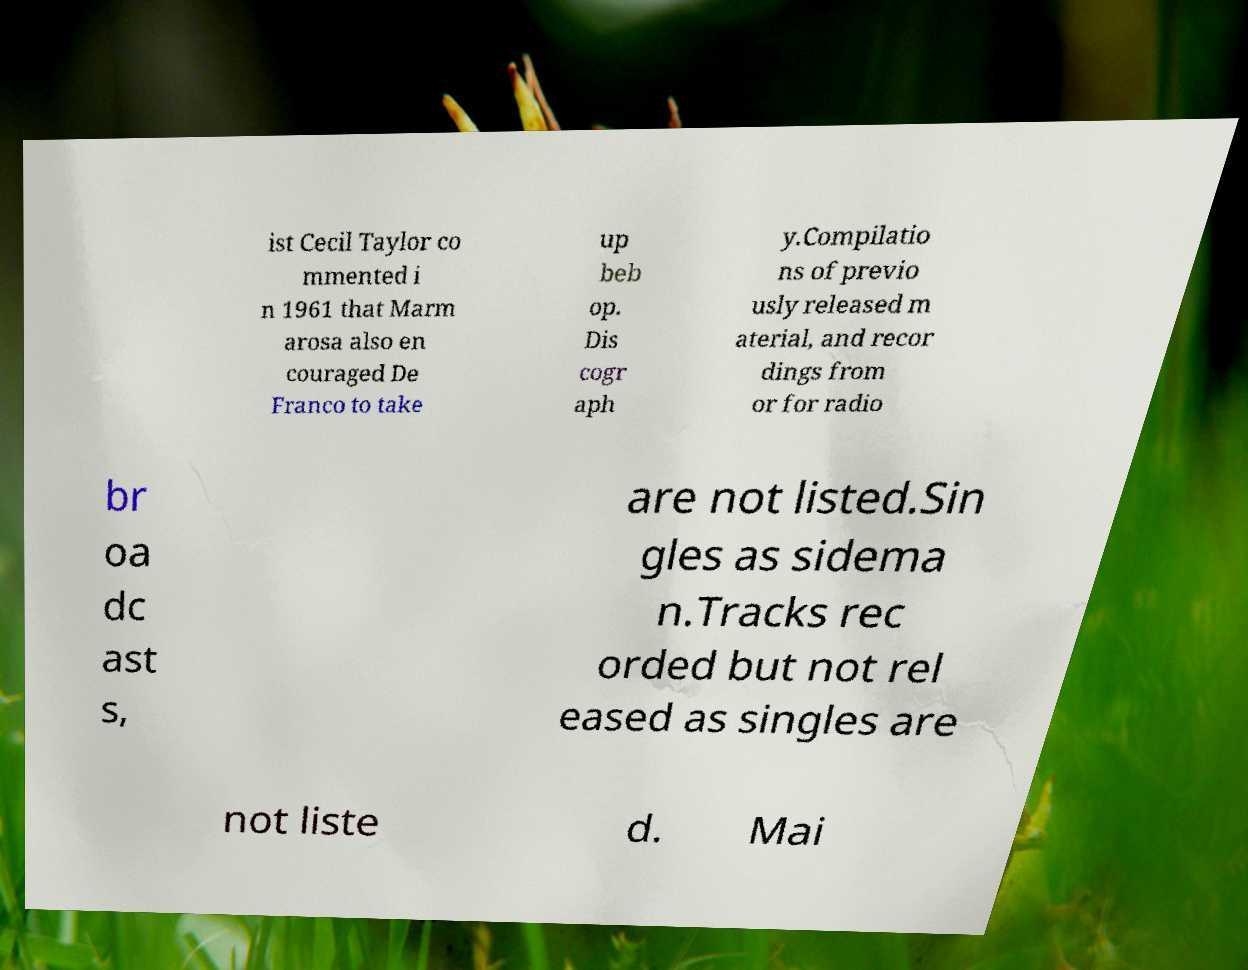Could you extract and type out the text from this image? ist Cecil Taylor co mmented i n 1961 that Marm arosa also en couraged De Franco to take up beb op. Dis cogr aph y.Compilatio ns of previo usly released m aterial, and recor dings from or for radio br oa dc ast s, are not listed.Sin gles as sidema n.Tracks rec orded but not rel eased as singles are not liste d. Mai 